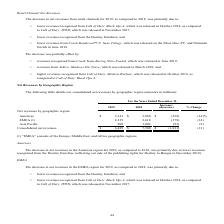According to Activision Blizzard's financial document, What does 'EMEA' consist of? the Europe, Middle East, and Africa geographic regions. The document states: "(1) “EMEA” consists of the Europe, Middle East, and Africa geographic regions...." Also, What was the primary reason for the decrease in net revenues in the Americas region for 2019 compared to 2018? lower revenues recognized from the Destiny franchise (reflecting our sale of the publishing rights for Destiny to Bungie in December 2018).. The document states: "or 2019, as compared to 2018, was primarily due to lower revenues recognized from the Destiny franchise (reflecting our sale of the publishing rights ..." Also, What was the net revenue from Americas in 2019? According to the financial document, $3,341 (in millions). The relevant text states: "Americas $ 3,341 $ 3,880 $ (539) (14)%..." Also, can you calculate: What was the total net revenues in 2019 of Americas and EMEA? Based on the calculation: ($3,341+2,239), the result is 5580 (in millions). This is based on the information: "EMEA (1) 2,239 2,618 (379) (14) Americas $ 3,341 $ 3,880 $ (539) (14)%..." The key data points involved are: 2,239, 3,341. Also, can you calculate: What was the total net revenues in 2018 of Americas and EMEA? Based on the calculation: $3,880+2,618, the result is 6498 (in millions). This is based on the information: "EMEA (1) 2,239 2,618 (379) (14) Americas $ 3,341 $ 3,880 $ (539) (14)%..." The key data points involved are: 2,618, 3,880. Also, can you calculate: What percentage of consolidated net revenue in 2019 consists of net revenue from Americas? Based on the calculation: ($3,341/$6,489), the result is 51.49 (percentage). This is based on the information: "Americas $ 3,341 $ 3,880 $ (539) (14)% Consolidated net revenues $ 6,489 $ 7,500 $ (1,011) (13)..." The key data points involved are: 3,341, 6,489. 